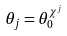Convert formula to latex. <formula><loc_0><loc_0><loc_500><loc_500>\theta _ { j } = \theta _ { 0 } ^ { \chi ^ { j } }</formula> 